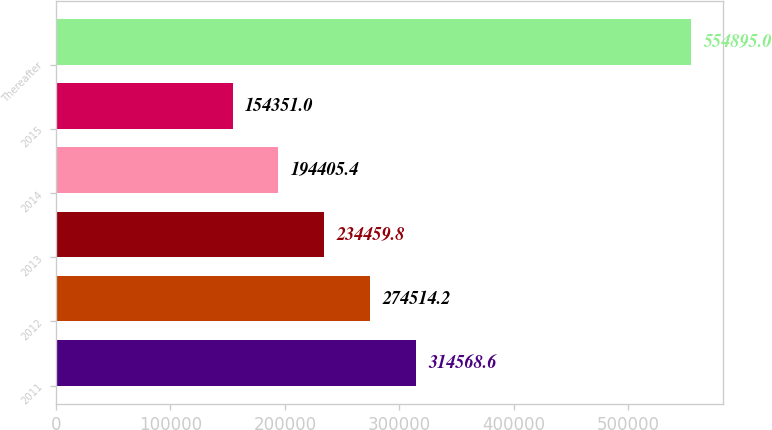Convert chart. <chart><loc_0><loc_0><loc_500><loc_500><bar_chart><fcel>2011<fcel>2012<fcel>2013<fcel>2014<fcel>2015<fcel>Thereafter<nl><fcel>314569<fcel>274514<fcel>234460<fcel>194405<fcel>154351<fcel>554895<nl></chart> 